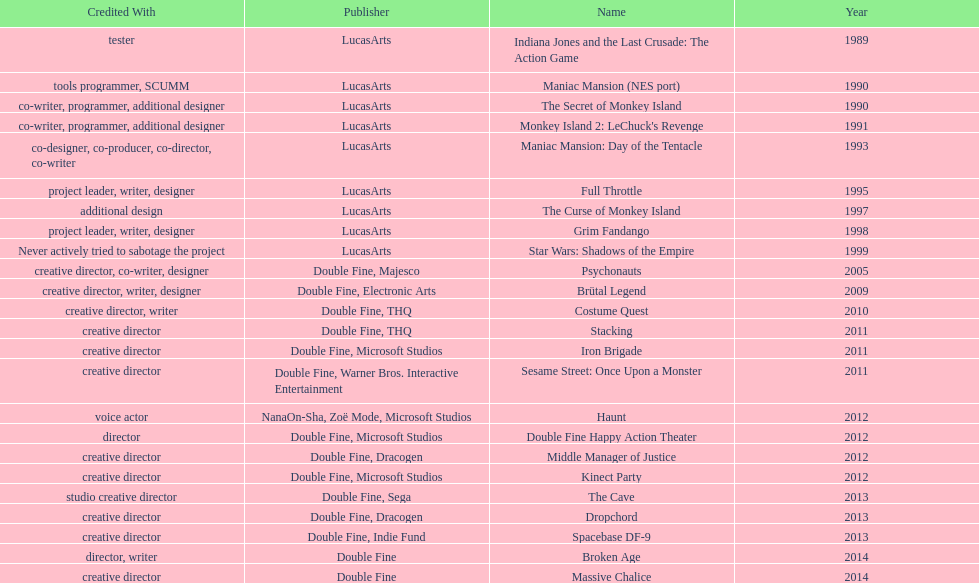How many games were credited with a creative director? 11. 